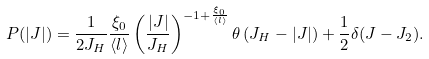Convert formula to latex. <formula><loc_0><loc_0><loc_500><loc_500>P ( | J | ) = \frac { 1 } { 2 J _ { H } } \frac { \xi _ { 0 } } { \langle l \rangle } \left ( \frac { | J | } { J _ { H } } \right ) ^ { - 1 + \frac { \xi _ { 0 } } { \langle l \rangle } } \theta \left ( J _ { H } - | J | \right ) + \frac { 1 } { 2 } \delta ( J - J _ { 2 } ) .</formula> 